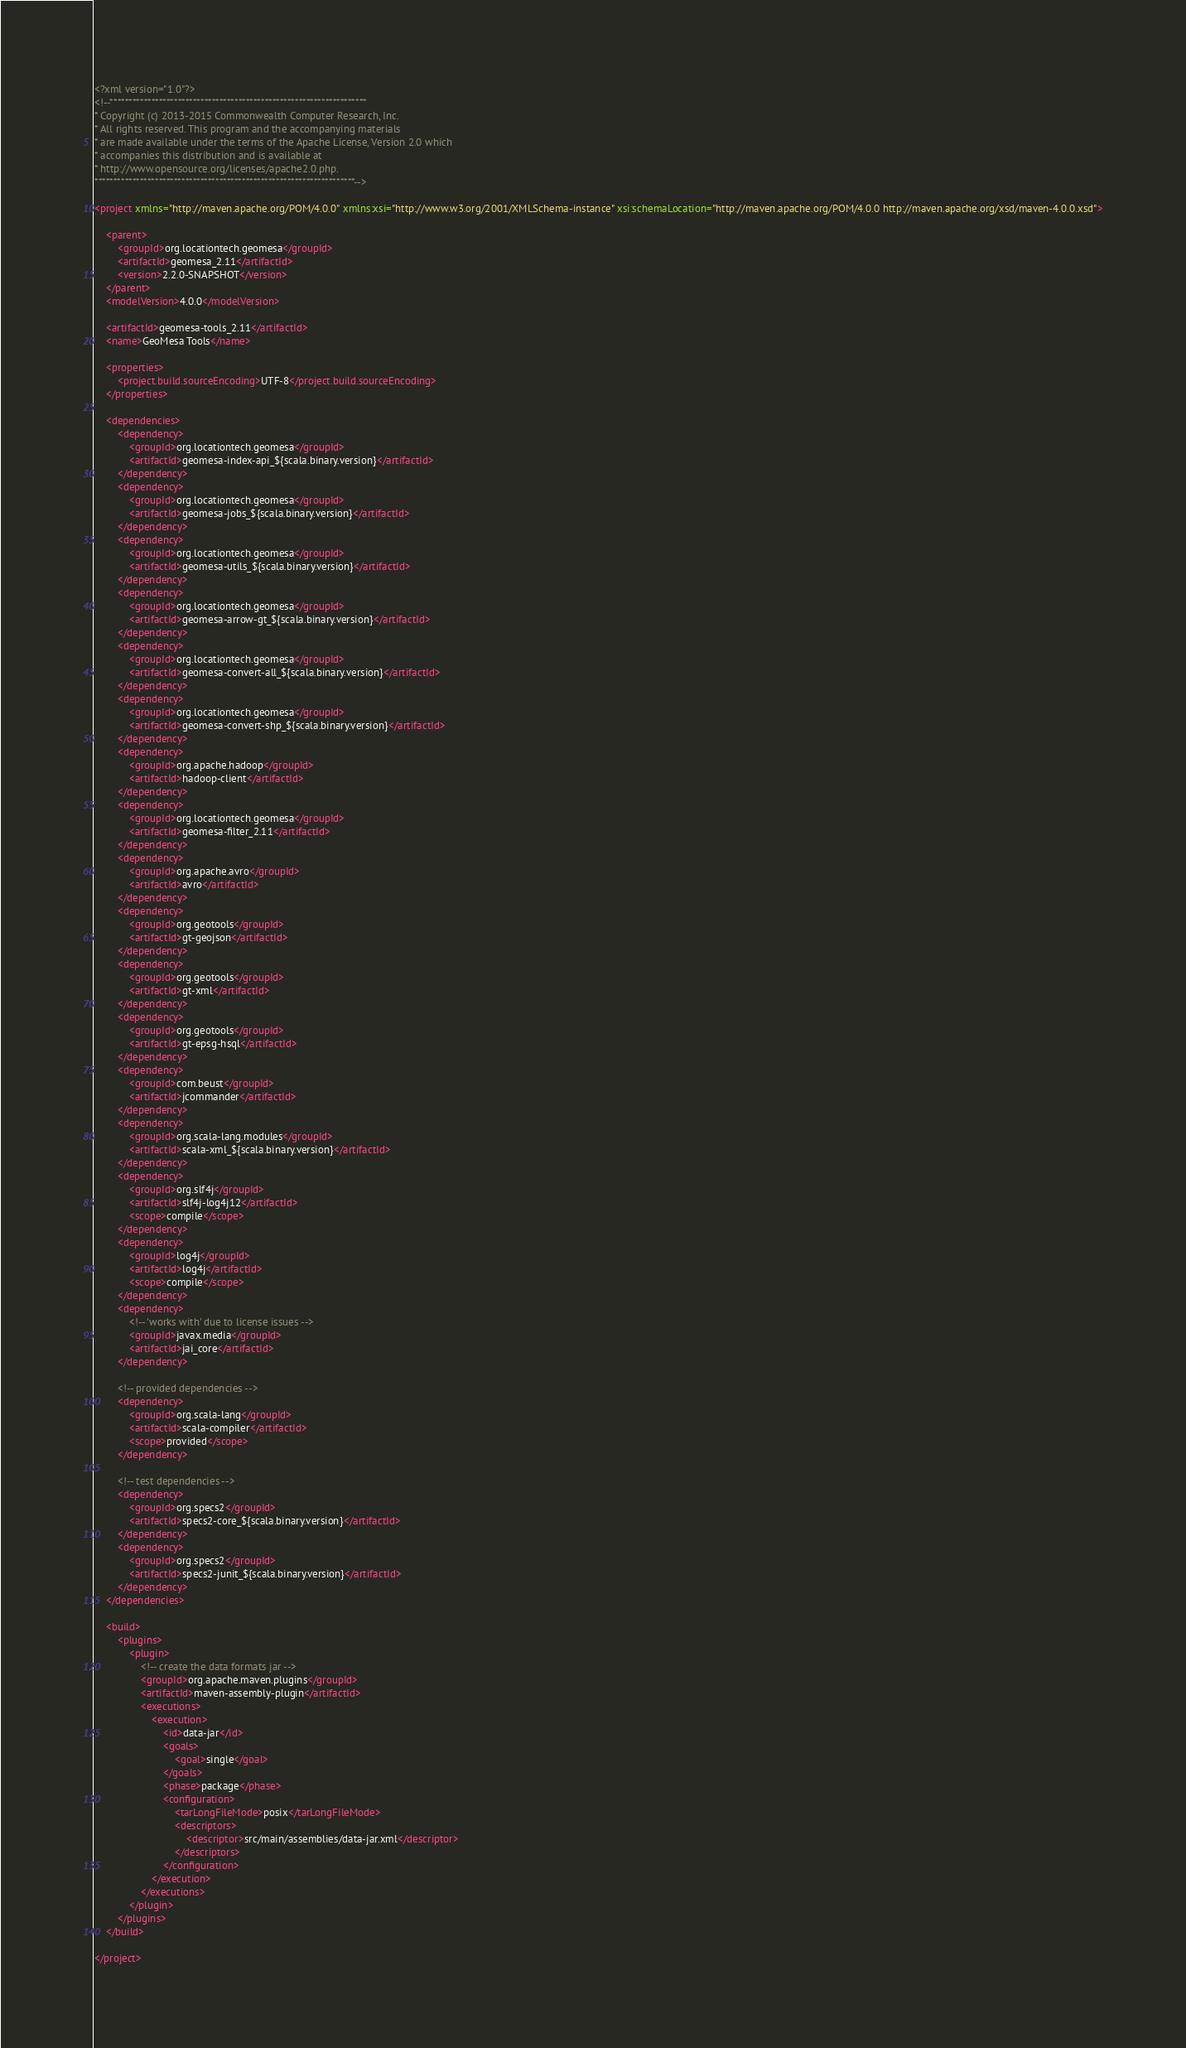<code> <loc_0><loc_0><loc_500><loc_500><_XML_><?xml version="1.0"?>
<!--********************************************************************
* Copyright (c) 2013-2015 Commonwealth Computer Research, Inc.
* All rights reserved. This program and the accompanying materials
* are made available under the terms of the Apache License, Version 2.0 which
* accompanies this distribution and is available at
* http://www.opensource.org/licenses/apache2.0.php.
*********************************************************************-->

<project xmlns="http://maven.apache.org/POM/4.0.0" xmlns:xsi="http://www.w3.org/2001/XMLSchema-instance" xsi:schemaLocation="http://maven.apache.org/POM/4.0.0 http://maven.apache.org/xsd/maven-4.0.0.xsd">

    <parent>
        <groupId>org.locationtech.geomesa</groupId>
        <artifactId>geomesa_2.11</artifactId>
        <version>2.2.0-SNAPSHOT</version>
    </parent>
    <modelVersion>4.0.0</modelVersion>

    <artifactId>geomesa-tools_2.11</artifactId>
    <name>GeoMesa Tools</name>

    <properties>
        <project.build.sourceEncoding>UTF-8</project.build.sourceEncoding>
    </properties>

    <dependencies>
        <dependency>
            <groupId>org.locationtech.geomesa</groupId>
            <artifactId>geomesa-index-api_${scala.binary.version}</artifactId>
        </dependency>
        <dependency>
            <groupId>org.locationtech.geomesa</groupId>
            <artifactId>geomesa-jobs_${scala.binary.version}</artifactId>
        </dependency>
        <dependency>
            <groupId>org.locationtech.geomesa</groupId>
            <artifactId>geomesa-utils_${scala.binary.version}</artifactId>
        </dependency>
        <dependency>
            <groupId>org.locationtech.geomesa</groupId>
            <artifactId>geomesa-arrow-gt_${scala.binary.version}</artifactId>
        </dependency>
        <dependency>
            <groupId>org.locationtech.geomesa</groupId>
            <artifactId>geomesa-convert-all_${scala.binary.version}</artifactId>
        </dependency>
        <dependency>
            <groupId>org.locationtech.geomesa</groupId>
            <artifactId>geomesa-convert-shp_${scala.binary.version}</artifactId>
        </dependency>
        <dependency>
            <groupId>org.apache.hadoop</groupId>
            <artifactId>hadoop-client</artifactId>
        </dependency>
        <dependency>
            <groupId>org.locationtech.geomesa</groupId>
            <artifactId>geomesa-filter_2.11</artifactId>
        </dependency>
        <dependency>
            <groupId>org.apache.avro</groupId>
            <artifactId>avro</artifactId>
        </dependency>
        <dependency>
            <groupId>org.geotools</groupId>
            <artifactId>gt-geojson</artifactId>
        </dependency>
        <dependency>
            <groupId>org.geotools</groupId>
            <artifactId>gt-xml</artifactId>
        </dependency>
        <dependency>
            <groupId>org.geotools</groupId>
            <artifactId>gt-epsg-hsql</artifactId>
        </dependency>
        <dependency>
            <groupId>com.beust</groupId>
            <artifactId>jcommander</artifactId>
        </dependency>
        <dependency>
            <groupId>org.scala-lang.modules</groupId>
            <artifactId>scala-xml_${scala.binary.version}</artifactId>
        </dependency>
        <dependency>
            <groupId>org.slf4j</groupId>
            <artifactId>slf4j-log4j12</artifactId>
            <scope>compile</scope>
        </dependency>
        <dependency>
            <groupId>log4j</groupId>
            <artifactId>log4j</artifactId>
            <scope>compile</scope>
        </dependency>
        <dependency>
            <!-- 'works with' due to license issues -->
            <groupId>javax.media</groupId>
            <artifactId>jai_core</artifactId>
        </dependency>

        <!-- provided dependencies -->
        <dependency>
            <groupId>org.scala-lang</groupId>
            <artifactId>scala-compiler</artifactId>
            <scope>provided</scope>
        </dependency>

        <!-- test dependencies -->
        <dependency>
            <groupId>org.specs2</groupId>
            <artifactId>specs2-core_${scala.binary.version}</artifactId>
        </dependency>
        <dependency>
            <groupId>org.specs2</groupId>
            <artifactId>specs2-junit_${scala.binary.version}</artifactId>
        </dependency>
    </dependencies>

    <build>
        <plugins>
            <plugin>
                <!-- create the data formats jar -->
                <groupId>org.apache.maven.plugins</groupId>
                <artifactId>maven-assembly-plugin</artifactId>
                <executions>
                    <execution>
                        <id>data-jar</id>
                        <goals>
                            <goal>single</goal>
                        </goals>
                        <phase>package</phase>
                        <configuration>
                            <tarLongFileMode>posix</tarLongFileMode>
                            <descriptors>
                                <descriptor>src/main/assemblies/data-jar.xml</descriptor>
                            </descriptors>
                        </configuration>
                    </execution>
                </executions>
            </plugin>
        </plugins>
    </build>

</project>
</code> 